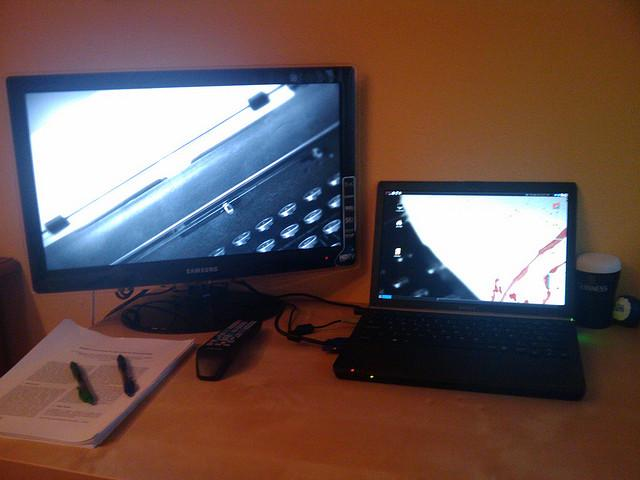By which technology standard is the monitor connected to the laptop? hdmi cable 